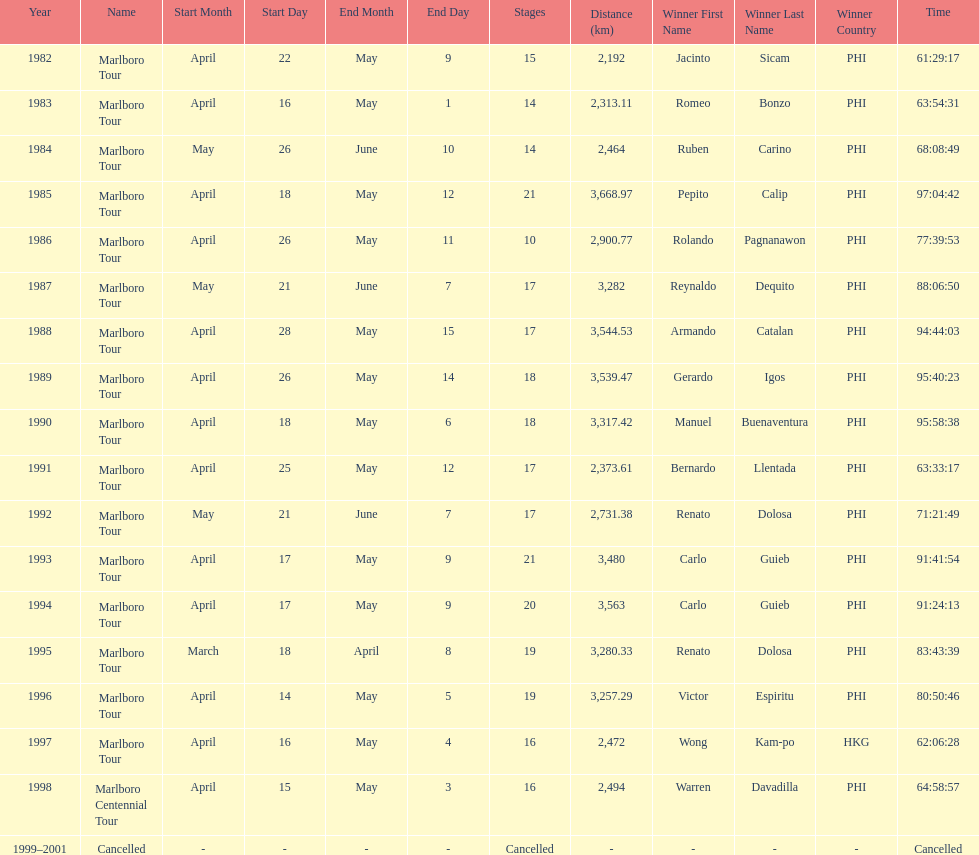Who is listed below romeo bonzo? Ruben Carino (PHI). 